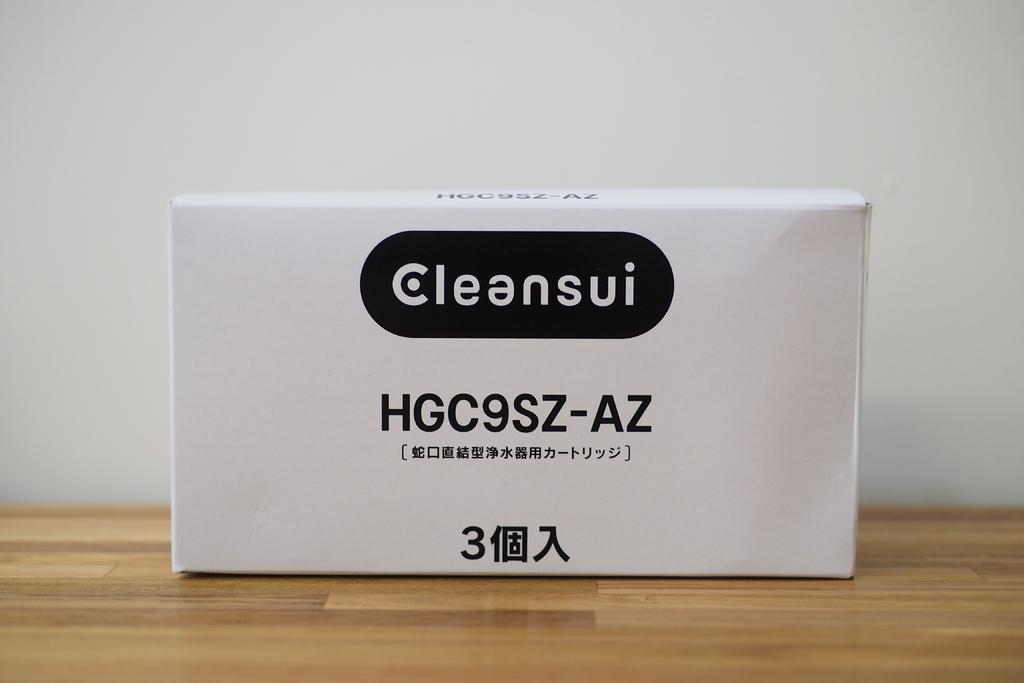What is the quantity of this product?
Make the answer very short. 3. What is the brand?
Offer a very short reply. Cleansui. 